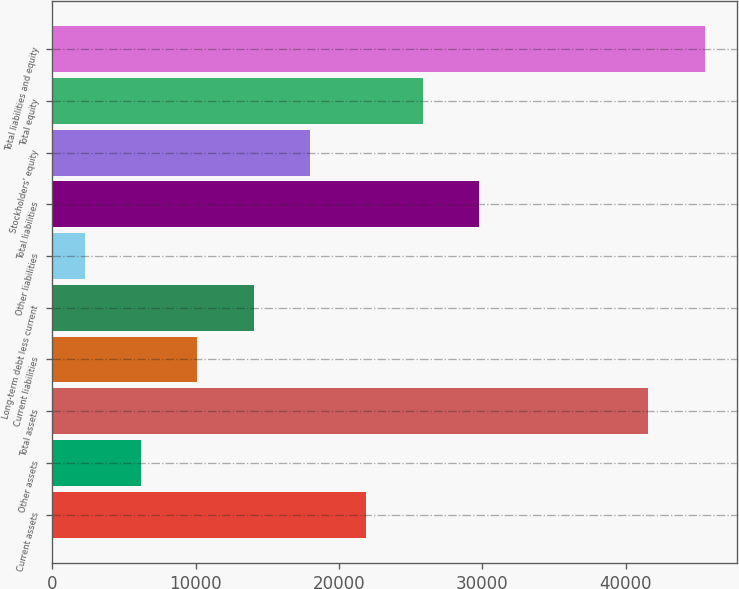Convert chart to OTSL. <chart><loc_0><loc_0><loc_500><loc_500><bar_chart><fcel>Current assets<fcel>Other assets<fcel>Total assets<fcel>Current liabilities<fcel>Long-term debt less current<fcel>Other liabilities<fcel>Total liabilities<fcel>Stockholders' equity<fcel>Total equity<fcel>Total liabilities and equity<nl><fcel>21921.5<fcel>6196.3<fcel>41578<fcel>10127.6<fcel>14058.9<fcel>2265<fcel>29784.1<fcel>17990.2<fcel>25852.8<fcel>45509.3<nl></chart> 